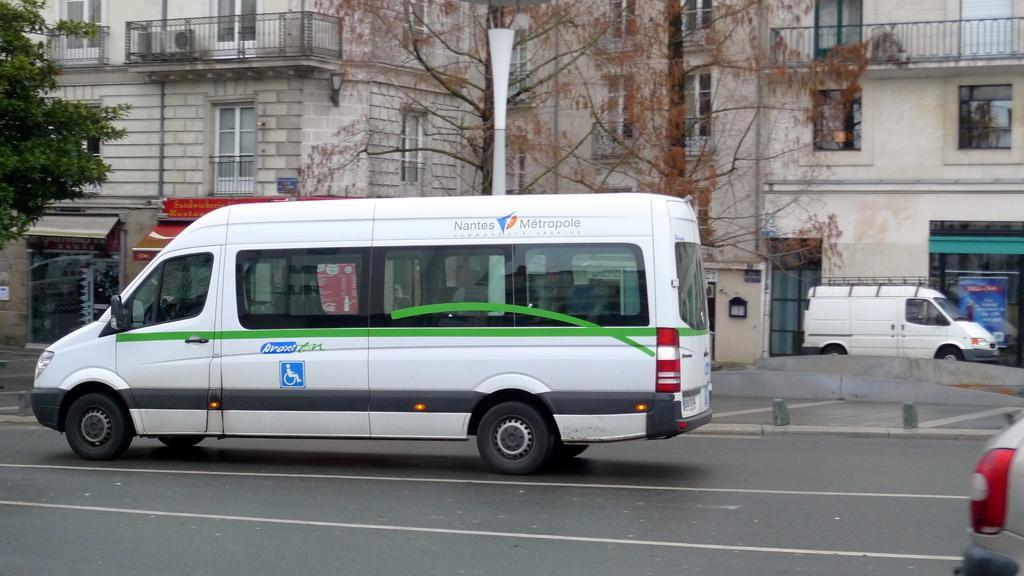Can you describe this image briefly? In this picture we can see white vehicles on the road with trees and houses on either side. 